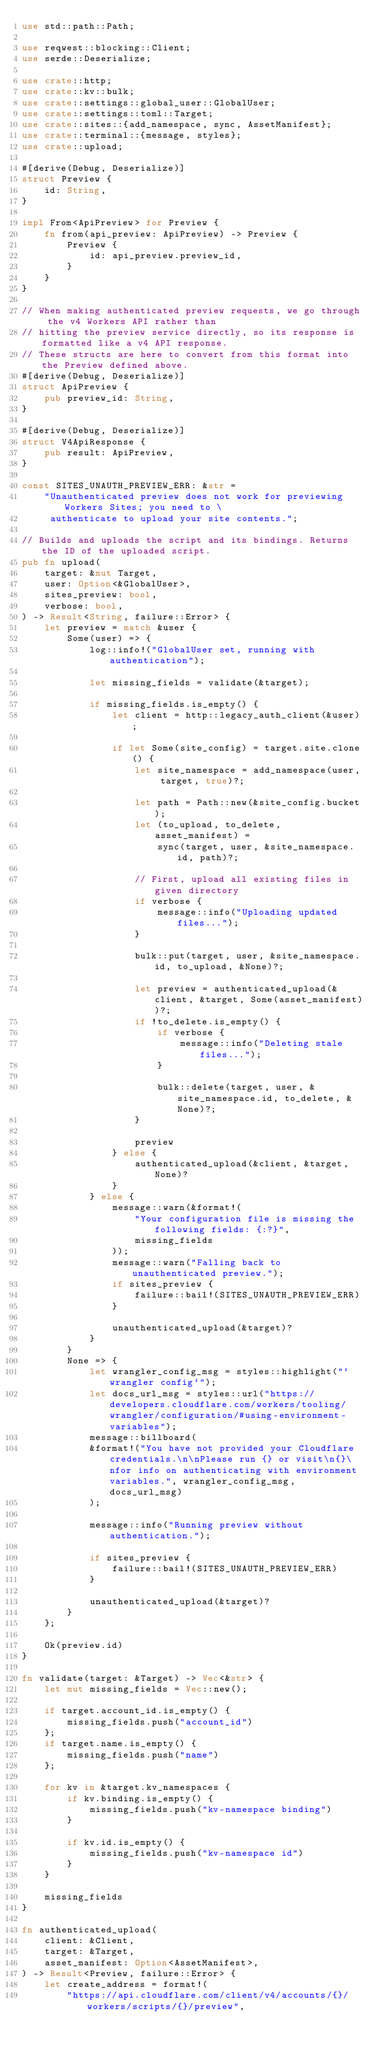<code> <loc_0><loc_0><loc_500><loc_500><_Rust_>use std::path::Path;

use reqwest::blocking::Client;
use serde::Deserialize;

use crate::http;
use crate::kv::bulk;
use crate::settings::global_user::GlobalUser;
use crate::settings::toml::Target;
use crate::sites::{add_namespace, sync, AssetManifest};
use crate::terminal::{message, styles};
use crate::upload;

#[derive(Debug, Deserialize)]
struct Preview {
    id: String,
}

impl From<ApiPreview> for Preview {
    fn from(api_preview: ApiPreview) -> Preview {
        Preview {
            id: api_preview.preview_id,
        }
    }
}

// When making authenticated preview requests, we go through the v4 Workers API rather than
// hitting the preview service directly, so its response is formatted like a v4 API response.
// These structs are here to convert from this format into the Preview defined above.
#[derive(Debug, Deserialize)]
struct ApiPreview {
    pub preview_id: String,
}

#[derive(Debug, Deserialize)]
struct V4ApiResponse {
    pub result: ApiPreview,
}

const SITES_UNAUTH_PREVIEW_ERR: &str =
    "Unauthenticated preview does not work for previewing Workers Sites; you need to \
     authenticate to upload your site contents.";

// Builds and uploads the script and its bindings. Returns the ID of the uploaded script.
pub fn upload(
    target: &mut Target,
    user: Option<&GlobalUser>,
    sites_preview: bool,
    verbose: bool,
) -> Result<String, failure::Error> {
    let preview = match &user {
        Some(user) => {
            log::info!("GlobalUser set, running with authentication");

            let missing_fields = validate(&target);

            if missing_fields.is_empty() {
                let client = http::legacy_auth_client(&user);

                if let Some(site_config) = target.site.clone() {
                    let site_namespace = add_namespace(user, target, true)?;

                    let path = Path::new(&site_config.bucket);
                    let (to_upload, to_delete, asset_manifest) =
                        sync(target, user, &site_namespace.id, path)?;

                    // First, upload all existing files in given directory
                    if verbose {
                        message::info("Uploading updated files...");
                    }

                    bulk::put(target, user, &site_namespace.id, to_upload, &None)?;

                    let preview = authenticated_upload(&client, &target, Some(asset_manifest))?;
                    if !to_delete.is_empty() {
                        if verbose {
                            message::info("Deleting stale files...");
                        }

                        bulk::delete(target, user, &site_namespace.id, to_delete, &None)?;
                    }

                    preview
                } else {
                    authenticated_upload(&client, &target, None)?
                }
            } else {
                message::warn(&format!(
                    "Your configuration file is missing the following fields: {:?}",
                    missing_fields
                ));
                message::warn("Falling back to unauthenticated preview.");
                if sites_preview {
                    failure::bail!(SITES_UNAUTH_PREVIEW_ERR)
                }

                unauthenticated_upload(&target)?
            }
        }
        None => {
            let wrangler_config_msg = styles::highlight("`wrangler config`");
            let docs_url_msg = styles::url("https://developers.cloudflare.com/workers/tooling/wrangler/configuration/#using-environment-variables");
            message::billboard(
            &format!("You have not provided your Cloudflare credentials.\n\nPlease run {} or visit\n{}\nfor info on authenticating with environment variables.", wrangler_config_msg, docs_url_msg)
            );

            message::info("Running preview without authentication.");

            if sites_preview {
                failure::bail!(SITES_UNAUTH_PREVIEW_ERR)
            }

            unauthenticated_upload(&target)?
        }
    };

    Ok(preview.id)
}

fn validate(target: &Target) -> Vec<&str> {
    let mut missing_fields = Vec::new();

    if target.account_id.is_empty() {
        missing_fields.push("account_id")
    };
    if target.name.is_empty() {
        missing_fields.push("name")
    };

    for kv in &target.kv_namespaces {
        if kv.binding.is_empty() {
            missing_fields.push("kv-namespace binding")
        }

        if kv.id.is_empty() {
            missing_fields.push("kv-namespace id")
        }
    }

    missing_fields
}

fn authenticated_upload(
    client: &Client,
    target: &Target,
    asset_manifest: Option<AssetManifest>,
) -> Result<Preview, failure::Error> {
    let create_address = format!(
        "https://api.cloudflare.com/client/v4/accounts/{}/workers/scripts/{}/preview",</code> 